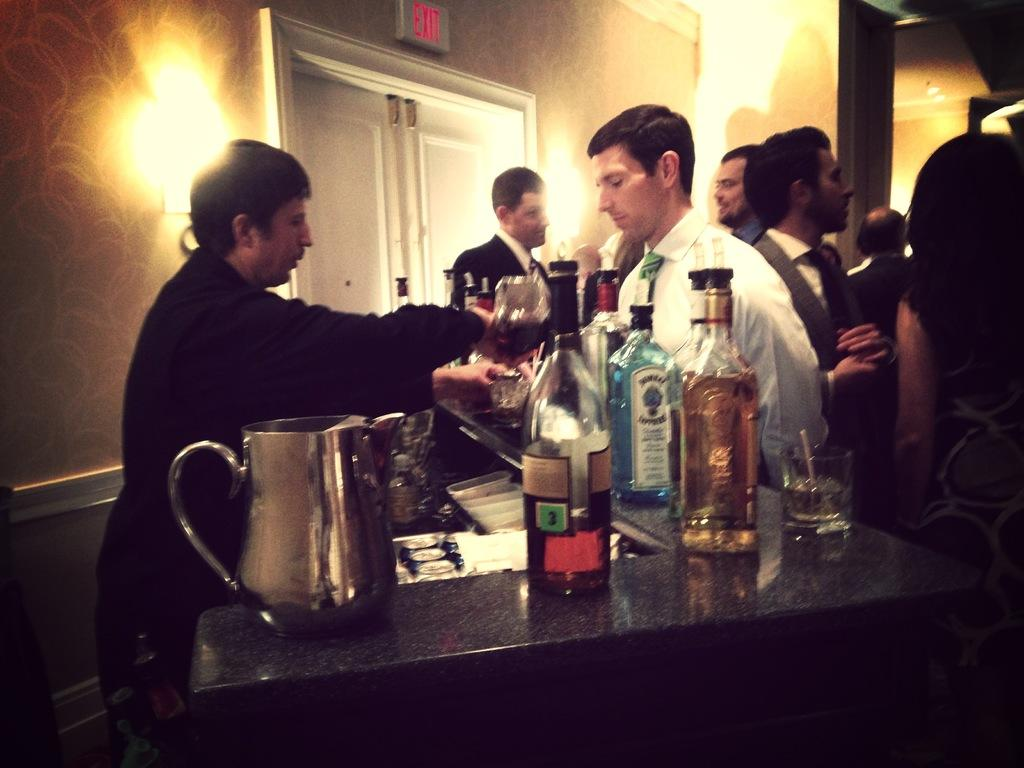<image>
Share a concise interpretation of the image provided. Bartender pouring drinks with a bottle with writing of Bombay Sapphire Gin 